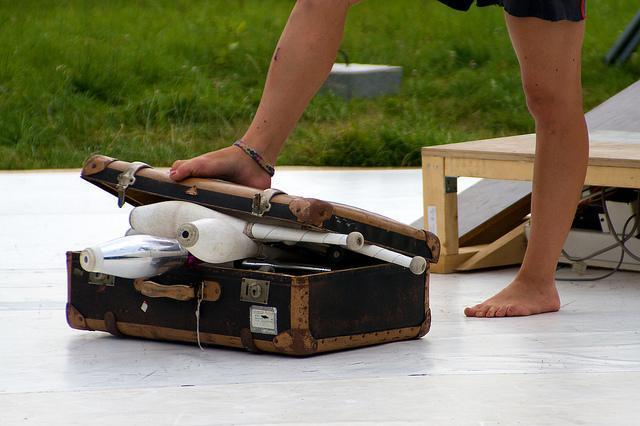How many people can you see?
Give a very brief answer. 1. How many airplanes are in the picture?
Give a very brief answer. 0. 